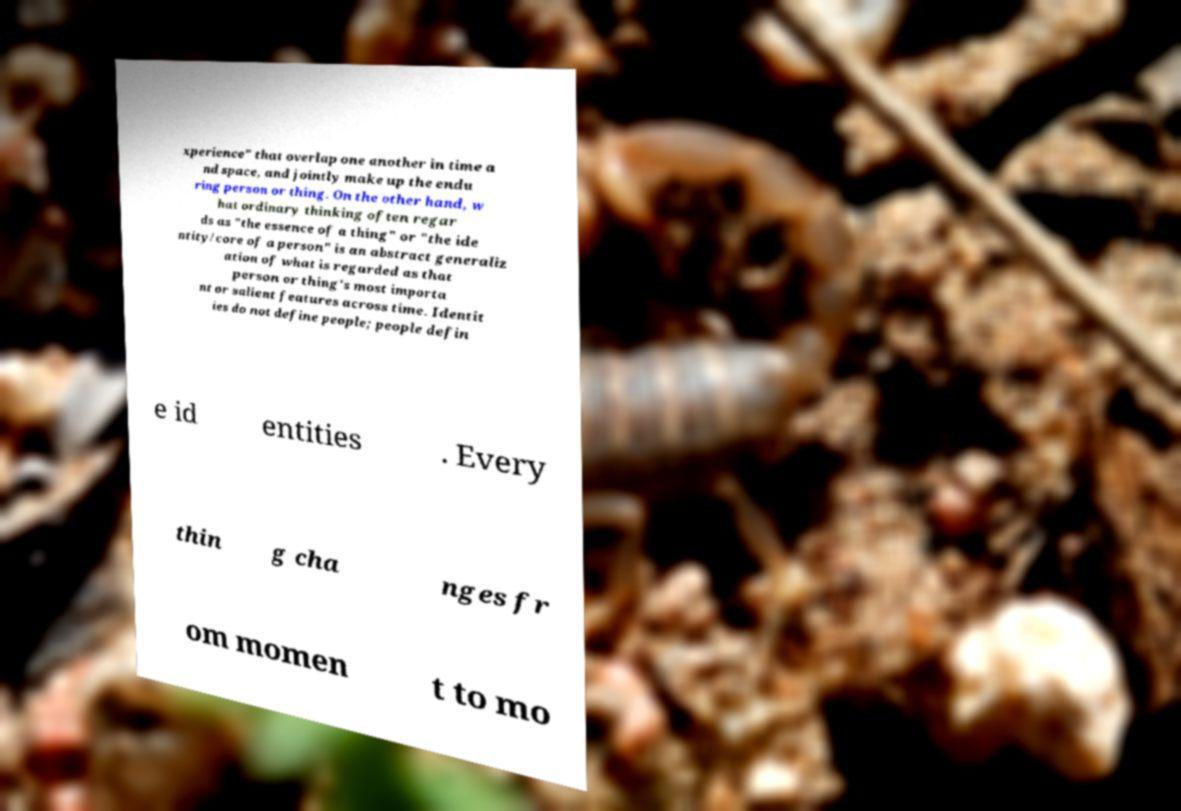Can you accurately transcribe the text from the provided image for me? xperience" that overlap one another in time a nd space, and jointly make up the endu ring person or thing. On the other hand, w hat ordinary thinking often regar ds as "the essence of a thing" or "the ide ntity/core of a person" is an abstract generaliz ation of what is regarded as that person or thing's most importa nt or salient features across time. Identit ies do not define people; people defin e id entities . Every thin g cha nges fr om momen t to mo 